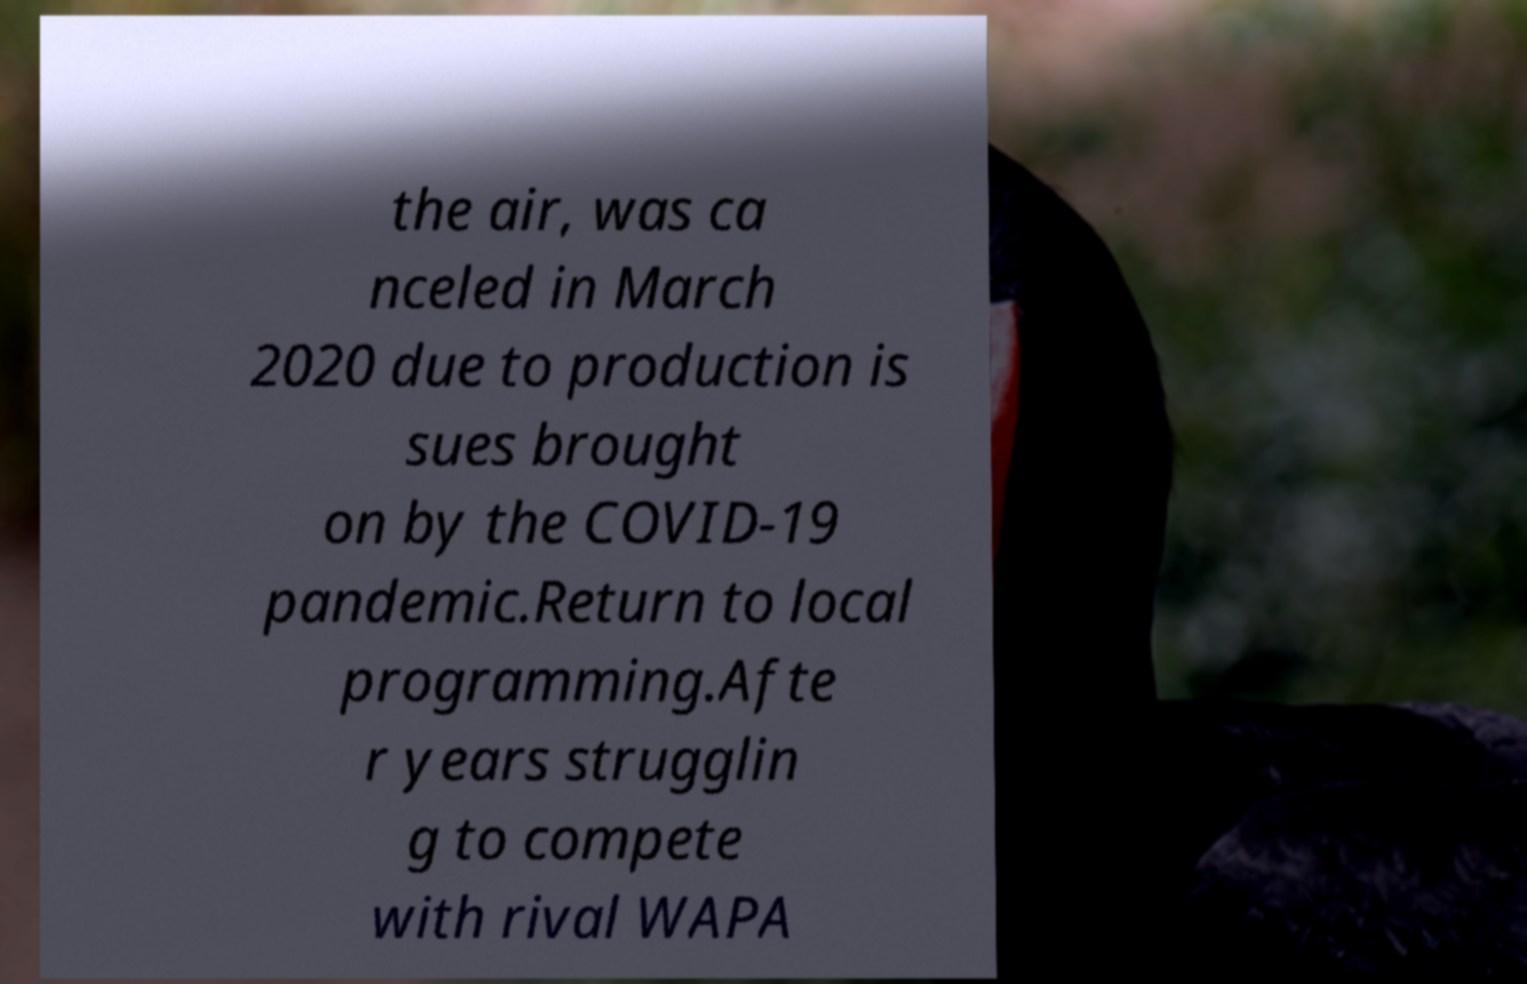There's text embedded in this image that I need extracted. Can you transcribe it verbatim? the air, was ca nceled in March 2020 due to production is sues brought on by the COVID-19 pandemic.Return to local programming.Afte r years strugglin g to compete with rival WAPA 